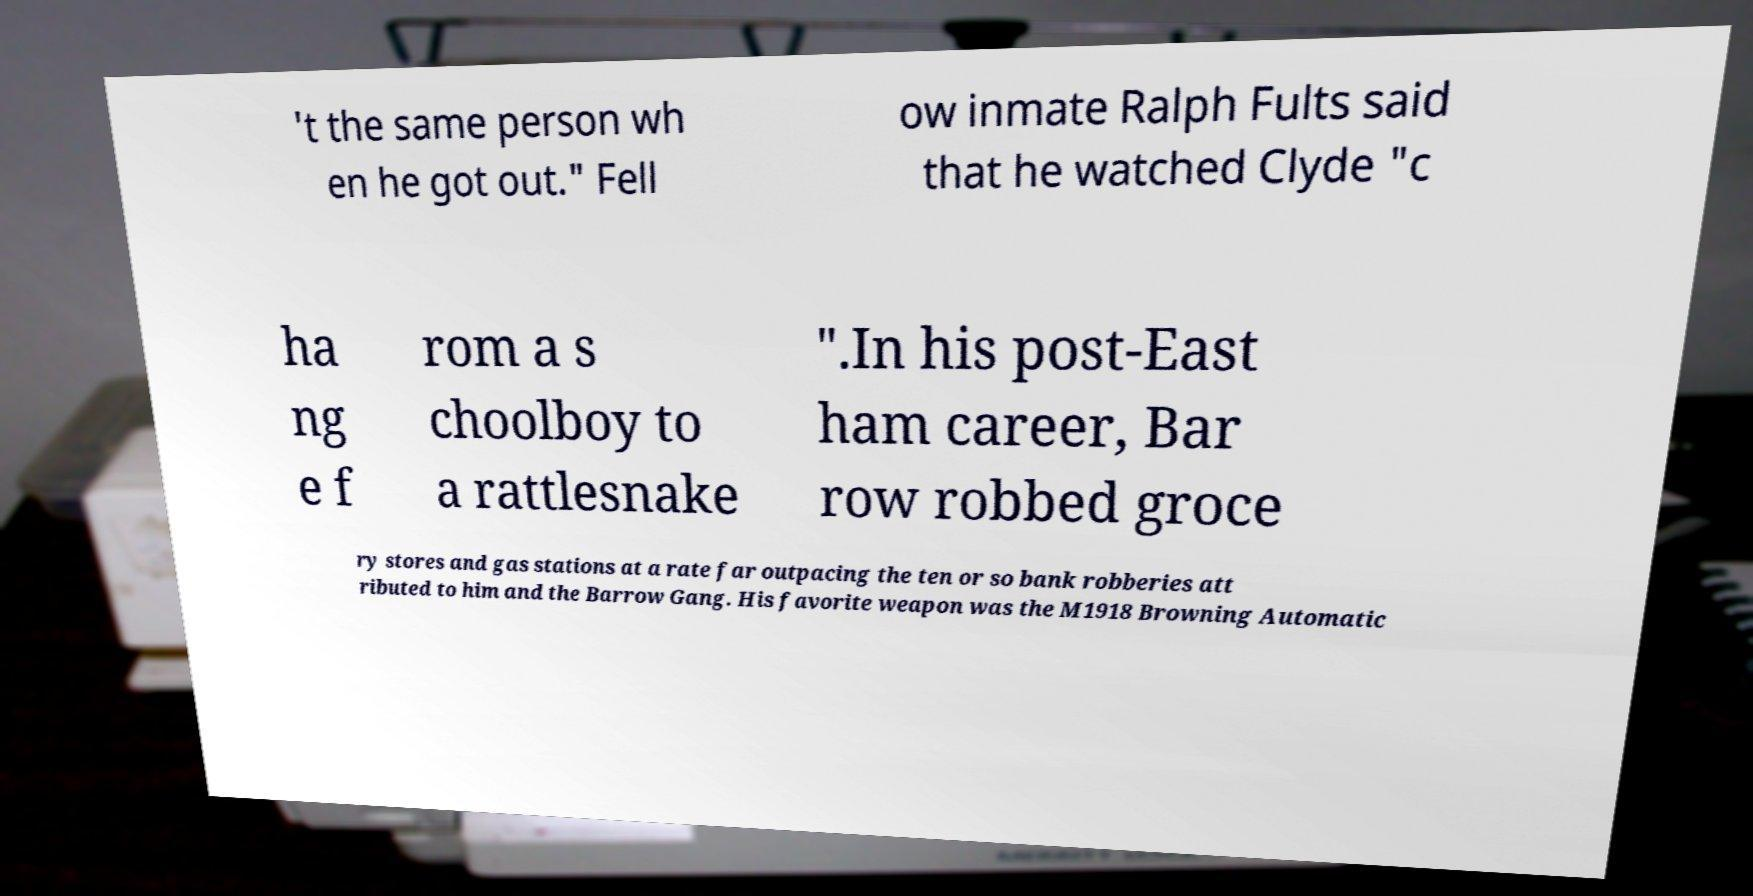Could you extract and type out the text from this image? 't the same person wh en he got out." Fell ow inmate Ralph Fults said that he watched Clyde "c ha ng e f rom a s choolboy to a rattlesnake ".In his post-East ham career, Bar row robbed groce ry stores and gas stations at a rate far outpacing the ten or so bank robberies att ributed to him and the Barrow Gang. His favorite weapon was the M1918 Browning Automatic 